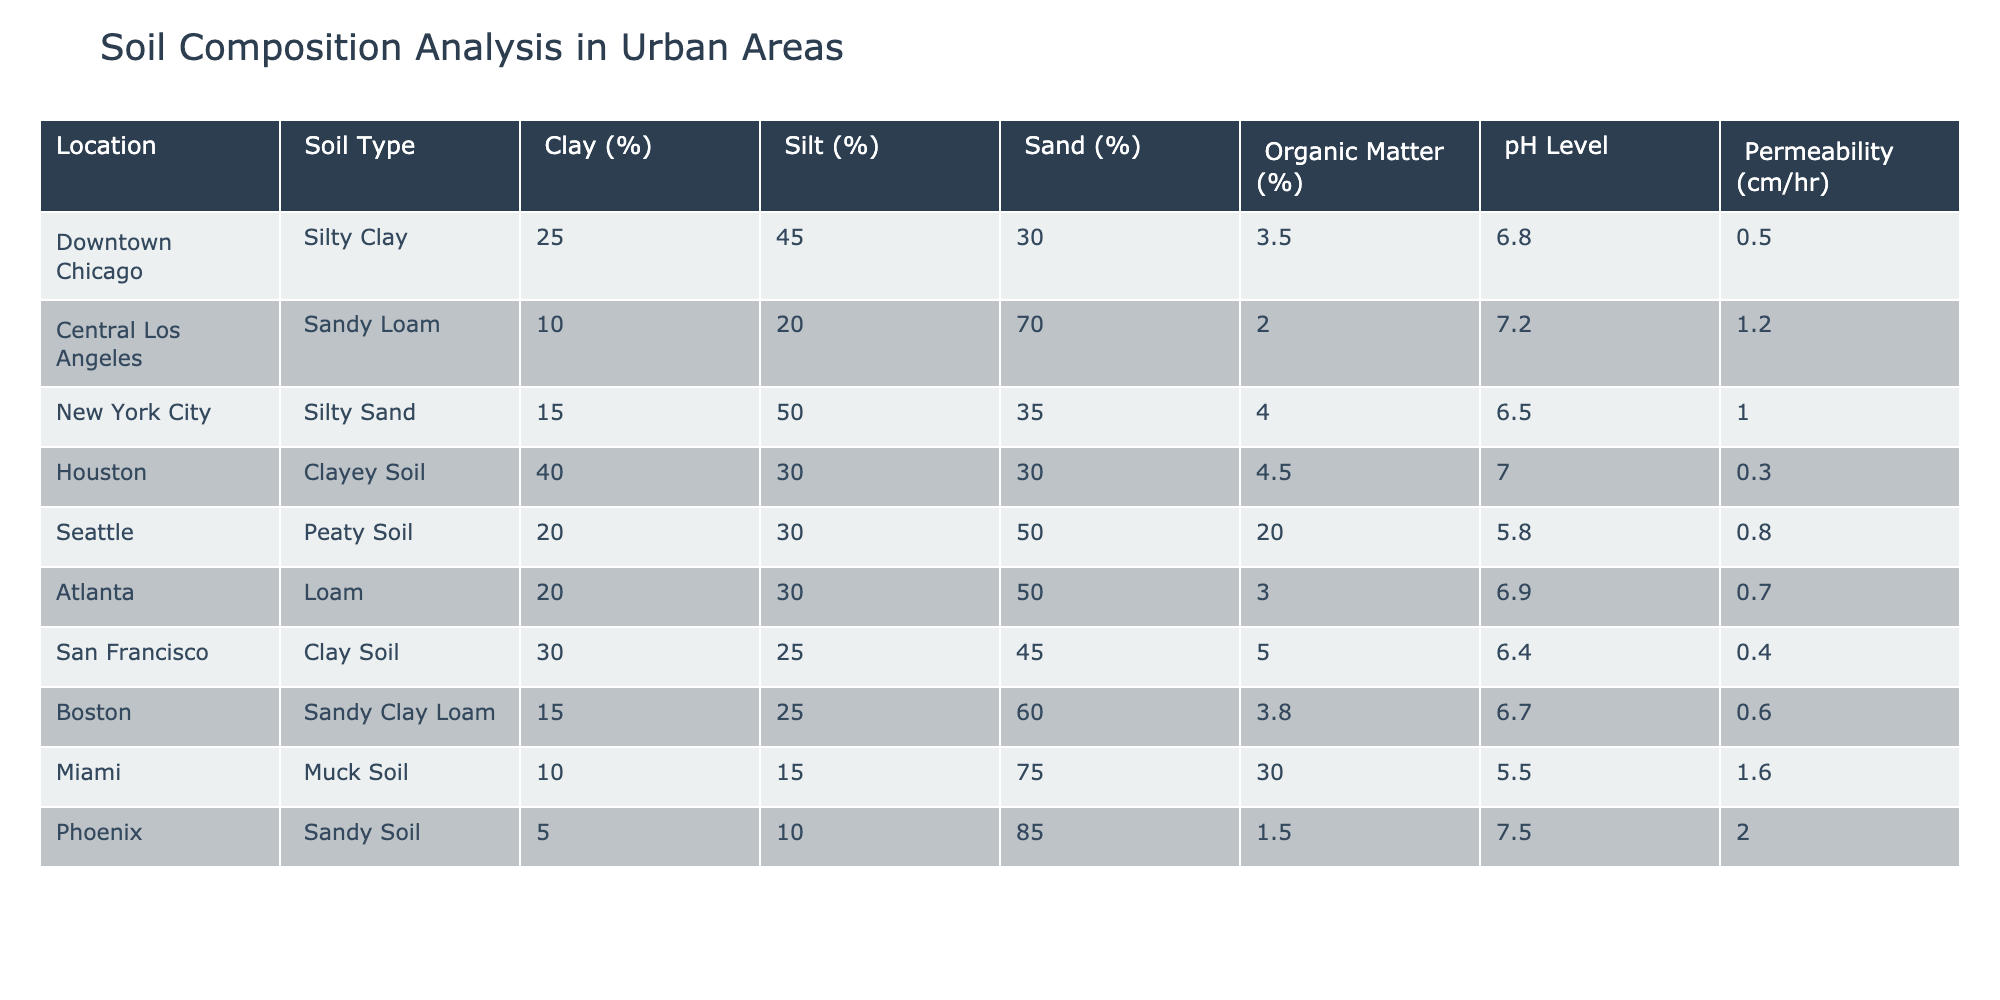What is the soil type in Downtown Chicago? The table clearly lists the soil type for each location. For Downtown Chicago, the corresponding value under "Soil Type" is "Silty Clay."
Answer: Silty Clay Which location has the highest percentage of organic matter? By checking the "Organic Matter (%)" column, Miami shows the highest percentage at 30.0%, compared to other locations listed.
Answer: Miami What is the average pH level of the soils listed? To find the average pH level, add up all the pH values: (6.8 + 7.2 + 6.5 + 7.0 + 5.8 + 6.9 + 6.4 + 6.7 + 5.5 + 7.5) = 68.7. Then divide this sum by the number of locations (10): 68.7 / 10 = 6.87.
Answer: 6.87 Is the permeability of Houston's soil higher than that of Downtown Chicago? From the table, Houston's permeability value is 0.3 cm/hr while Downtown Chicago's is 0.5 cm/hr. Since 0.3 is less than 0.5, the statement is false.
Answer: No What is the difference in clay percentage between Central Los Angeles and Miami? Central Los Angeles has 10% clay and Miami has 10% clay. The difference is calculated as 10 - 10 = 0%.
Answer: 0% Which location has the lowest average of sand and silt percentages combined? To find this, we calculate the sum of sand and silt percentages for each location. For example, for Downtown Chicago: 45 + 30 = 75. Adding these sums for each location, we find that Houston has the lowest total at 30 + 40 = 70. Among all locations, Houston has the lowest average combined percentage of sand and silt.
Answer: Houston Is there a location where the pH level is below 6.0? Reviewing the "pH Level" column, we see that Seattle has a pH level of 5.8, which is below 6.0. Therefore, this statement is true.
Answer: Yes Which soil type has the highest silt percentage? From the table, Seattle (Peaty Soil) has 30% silt, but the highest silt percentage is found in New York City (50% silt) as per the "Silt (%)" column.
Answer: Silty Sand What is the sum of clay percentages for all the locations combined? The sum of clay percentages is calculated as follows: 25 + 10 + 15 + 40 + 20 + 20 + 30 + 15 + 10 + 5 = 225%.
Answer: 225 